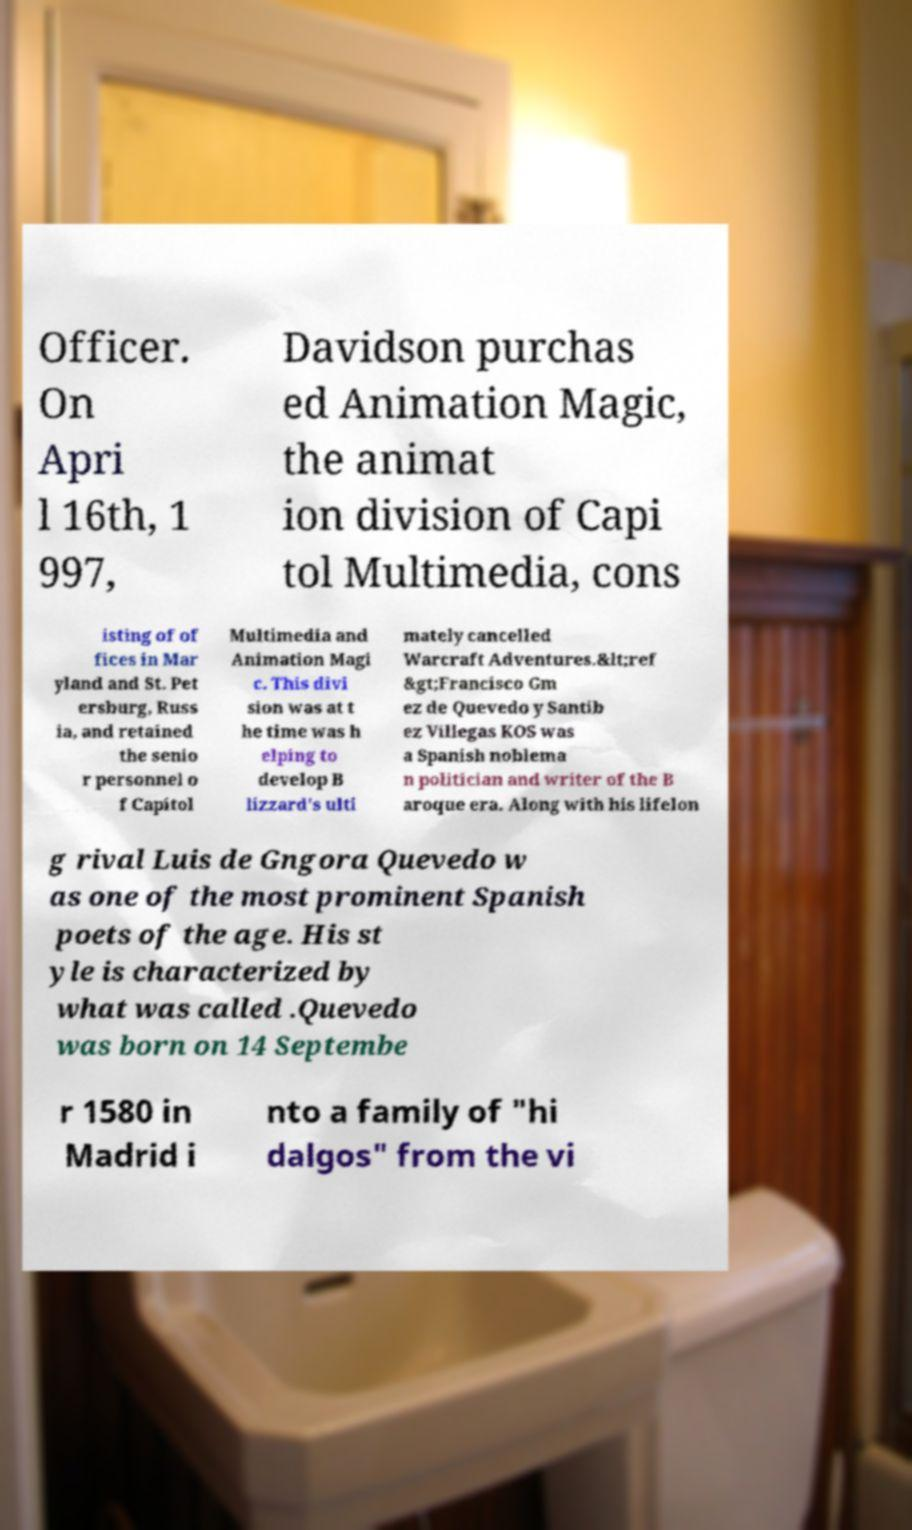Can you accurately transcribe the text from the provided image for me? Officer. On Apri l 16th, 1 997, Davidson purchas ed Animation Magic, the animat ion division of Capi tol Multimedia, cons isting of of fices in Mar yland and St. Pet ersburg, Russ ia, and retained the senio r personnel o f Capitol Multimedia and Animation Magi c. This divi sion was at t he time was h elping to develop B lizzard's ulti mately cancelled Warcraft Adventures.&lt;ref &gt;Francisco Gm ez de Quevedo y Santib ez Villegas KOS was a Spanish noblema n politician and writer of the B aroque era. Along with his lifelon g rival Luis de Gngora Quevedo w as one of the most prominent Spanish poets of the age. His st yle is characterized by what was called .Quevedo was born on 14 Septembe r 1580 in Madrid i nto a family of "hi dalgos" from the vi 